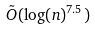Convert formula to latex. <formula><loc_0><loc_0><loc_500><loc_500>\tilde { O } ( \log ( n ) ^ { 7 . 5 } )</formula> 